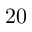Convert formula to latex. <formula><loc_0><loc_0><loc_500><loc_500>2 0</formula> 